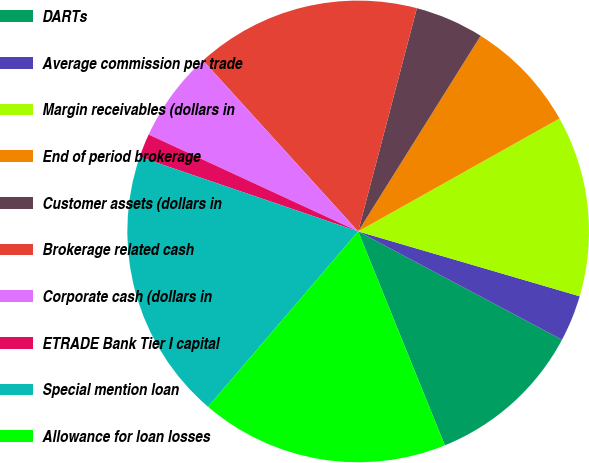Convert chart to OTSL. <chart><loc_0><loc_0><loc_500><loc_500><pie_chart><fcel>DARTs<fcel>Average commission per trade<fcel>Margin receivables (dollars in<fcel>End of period brokerage<fcel>Customer assets (dollars in<fcel>Brokerage related cash<fcel>Corporate cash (dollars in<fcel>ETRADE Bank Tier I capital<fcel>Special mention loan<fcel>Allowance for loan losses<nl><fcel>11.1%<fcel>3.24%<fcel>12.67%<fcel>7.96%<fcel>4.81%<fcel>15.82%<fcel>6.38%<fcel>1.66%<fcel>18.97%<fcel>17.39%<nl></chart> 